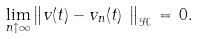Convert formula to latex. <formula><loc_0><loc_0><loc_500><loc_500>\lim _ { n \uparrow \infty } \left \| v ( t ) - v _ { n } ( t ) _ { \, _ { \, _ { \, } } } \right \| _ { \mathcal { H } } \, = \, 0 .</formula> 